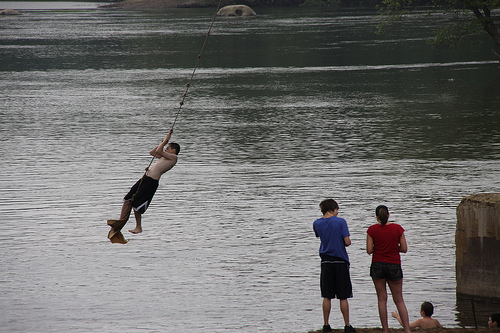<image>
Can you confirm if the boy is on the rope? Yes. Looking at the image, I can see the boy is positioned on top of the rope, with the rope providing support. 